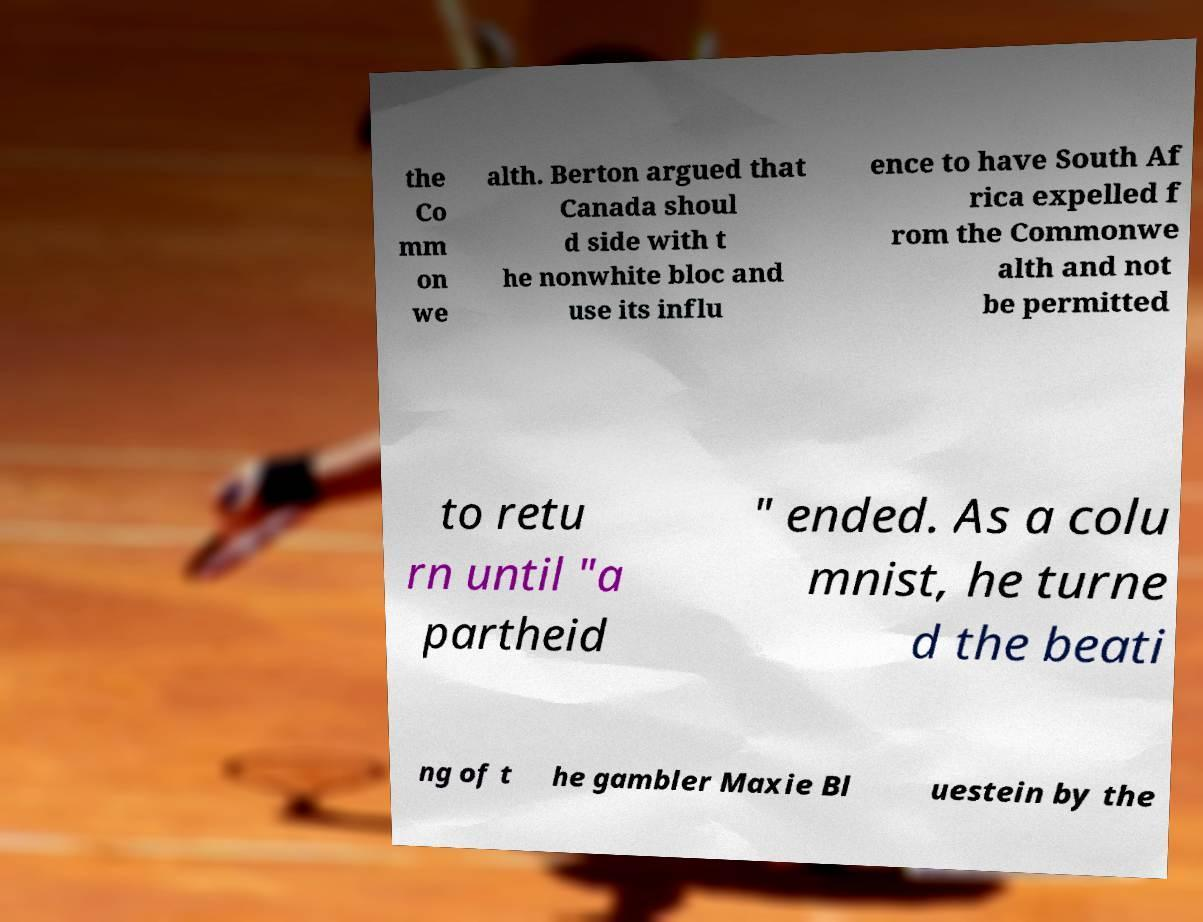Can you read and provide the text displayed in the image?This photo seems to have some interesting text. Can you extract and type it out for me? the Co mm on we alth. Berton argued that Canada shoul d side with t he nonwhite bloc and use its influ ence to have South Af rica expelled f rom the Commonwe alth and not be permitted to retu rn until "a partheid " ended. As a colu mnist, he turne d the beati ng of t he gambler Maxie Bl uestein by the 